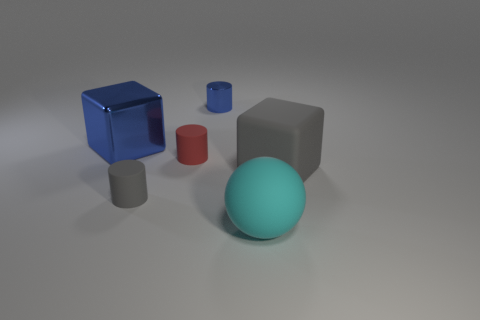Add 3 tiny cylinders. How many objects exist? 9 Subtract all blocks. How many objects are left? 4 Add 3 big cyan objects. How many big cyan objects exist? 4 Subtract 1 blue blocks. How many objects are left? 5 Subtract all big red shiny cubes. Subtract all tiny red cylinders. How many objects are left? 5 Add 2 red rubber things. How many red rubber things are left? 3 